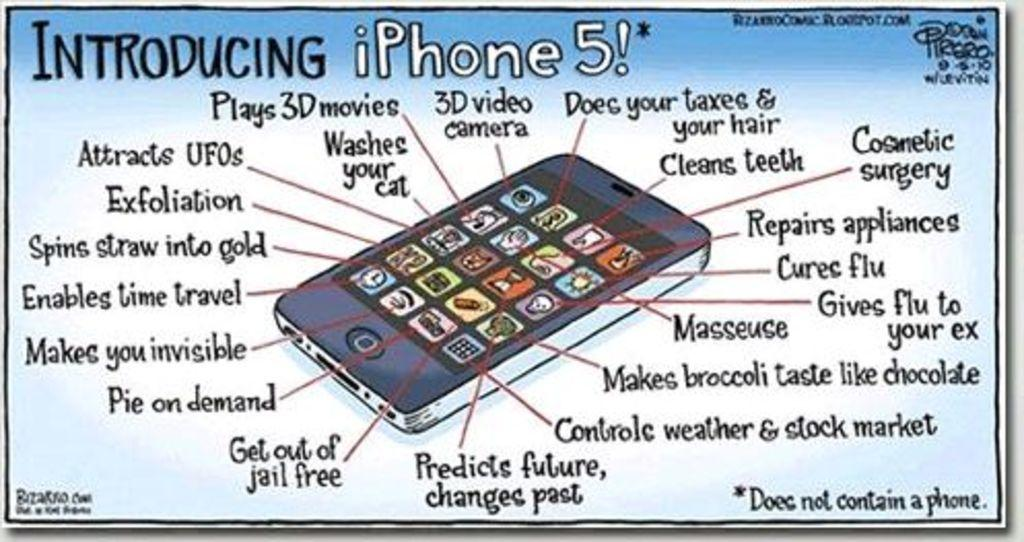<image>
Create a compact narrative representing the image presented. A cartoon like drawing of and Iphone 5 introducing the product and its features. 